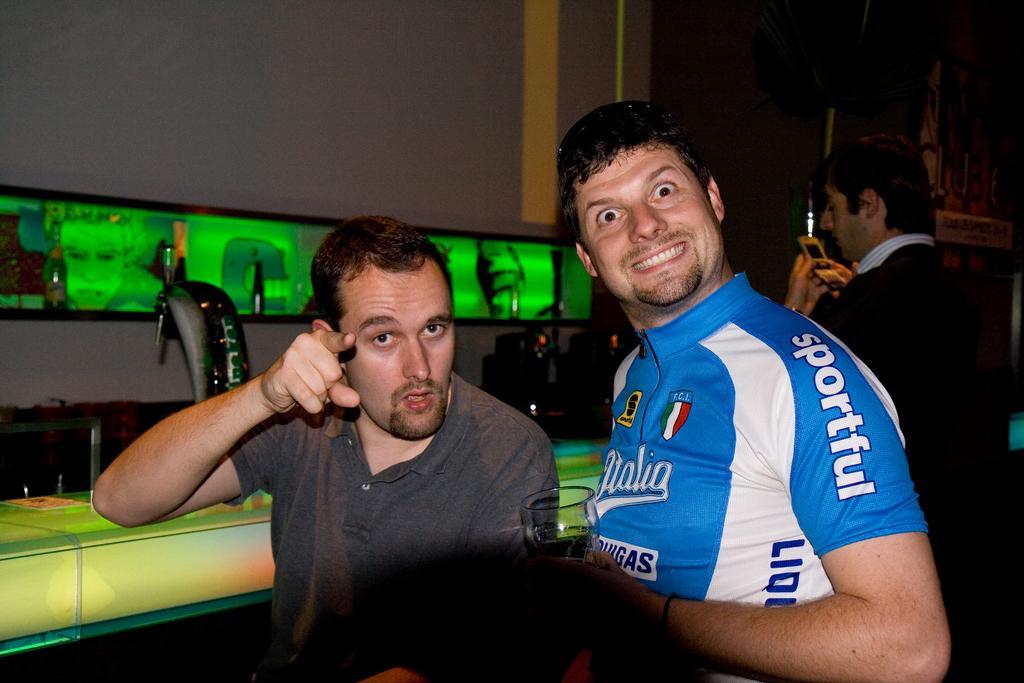Can you describe this image briefly? In this picture I can see three men, on the left side those look like the electronic displays with the lights and there are machines. 